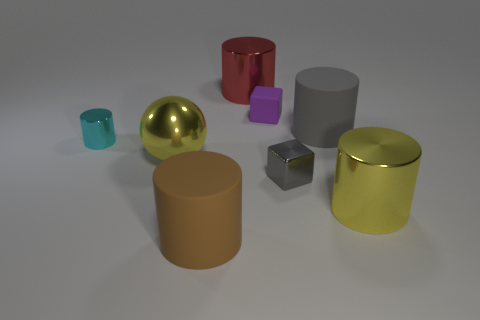Add 1 big yellow metallic things. How many objects exist? 9 Subtract all cyan cylinders. How many cylinders are left? 4 Subtract all large gray cylinders. How many cylinders are left? 4 Subtract all cylinders. How many objects are left? 3 Subtract 1 balls. How many balls are left? 0 Subtract all gray metal cylinders. Subtract all big brown cylinders. How many objects are left? 7 Add 1 big shiny things. How many big shiny things are left? 4 Add 6 big green metallic things. How many big green metallic things exist? 6 Subtract 0 green cylinders. How many objects are left? 8 Subtract all yellow blocks. Subtract all red balls. How many blocks are left? 2 